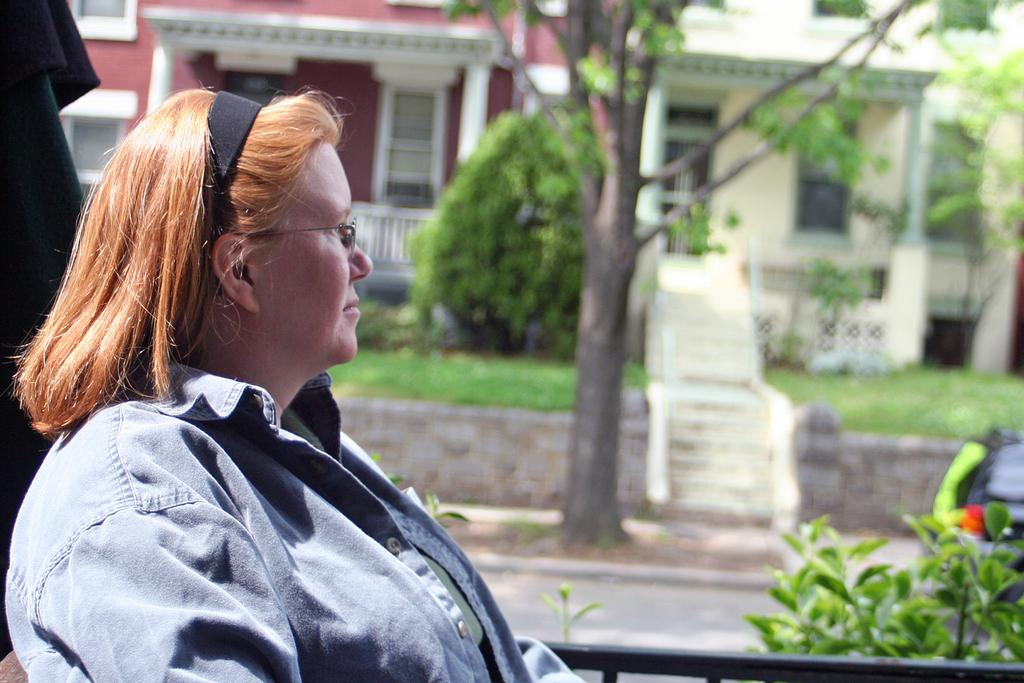Who is present in the image? There is a woman in the image. What is the woman wearing on her upper body? The woman is wearing a shirt. What accessory is the woman wearing on her face? The woman is wearing spectacles. Can you describe the background of the image? The background of the image is blurred. What can be seen on the road in the background? There is a car visible on the road in the background. What type of natural environment is visible in the background? There are trees in the background. What type of man-made structures are visible in the background? There are houses in the background. What is the woman's opinion on the iron in the image? There is no iron present in the image, and therefore no such discussion can be had about the woman's opinion. Can you describe the snake in the image? There is no snake present in the image. 